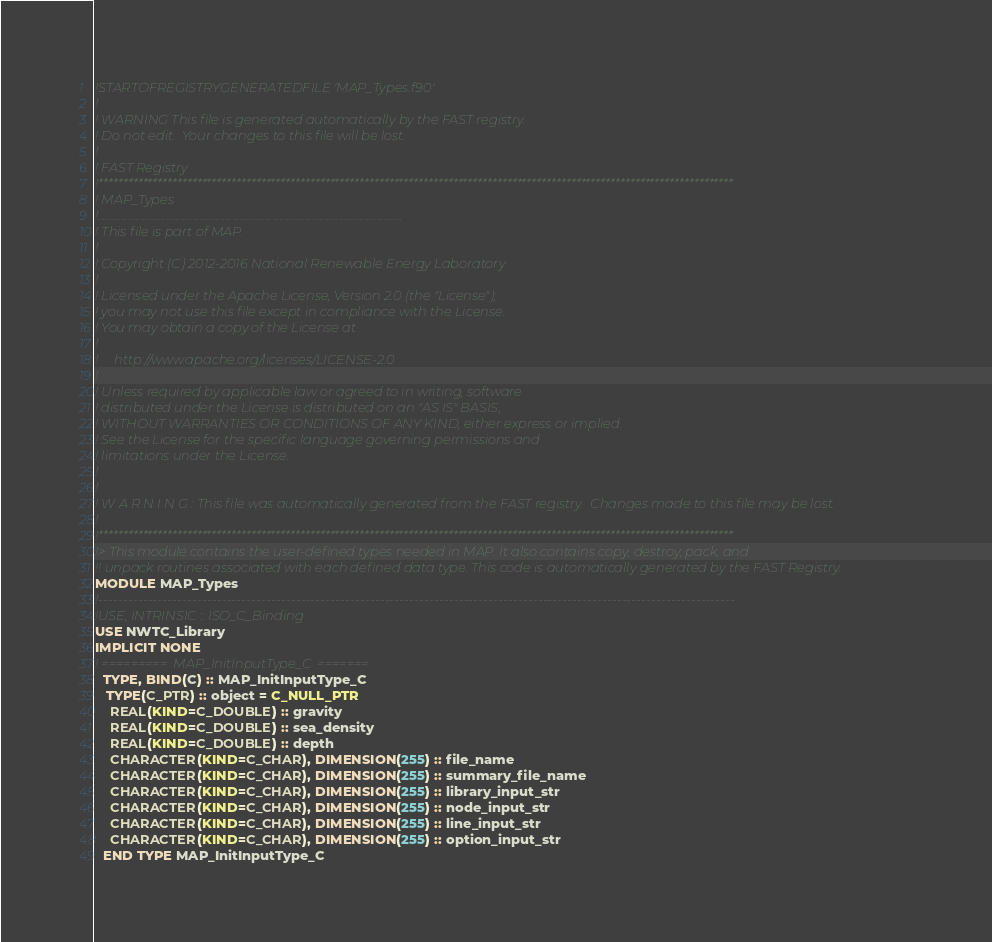Convert code to text. <code><loc_0><loc_0><loc_500><loc_500><_FORTRAN_>!STARTOFREGISTRYGENERATEDFILE 'MAP_Types.f90'
!
! WARNING This file is generated automatically by the FAST registry.
! Do not edit.  Your changes to this file will be lost.
!
! FAST Registry
!*********************************************************************************************************************************
! MAP_Types
!.................................................................................................................................
! This file is part of MAP.
!
! Copyright (C) 2012-2016 National Renewable Energy Laboratory
!
! Licensed under the Apache License, Version 2.0 (the "License");
! you may not use this file except in compliance with the License.
! You may obtain a copy of the License at
!
!     http://www.apache.org/licenses/LICENSE-2.0
!
! Unless required by applicable law or agreed to in writing, software
! distributed under the License is distributed on an "AS IS" BASIS,
! WITHOUT WARRANTIES OR CONDITIONS OF ANY KIND, either express or implied.
! See the License for the specific language governing permissions and
! limitations under the License.
!
!
! W A R N I N G : This file was automatically generated from the FAST registry.  Changes made to this file may be lost.
!
!*********************************************************************************************************************************
!> This module contains the user-defined types needed in MAP. It also contains copy, destroy, pack, and
!! unpack routines associated with each defined data type. This code is automatically generated by the FAST Registry.
MODULE MAP_Types
!---------------------------------------------------------------------------------------------------------------------------------
!USE, INTRINSIC :: ISO_C_Binding
USE NWTC_Library
IMPLICIT NONE
! =========  MAP_InitInputType_C  =======
  TYPE, BIND(C) :: MAP_InitInputType_C
   TYPE(C_PTR) :: object = C_NULL_PTR
    REAL(KIND=C_DOUBLE) :: gravity 
    REAL(KIND=C_DOUBLE) :: sea_density 
    REAL(KIND=C_DOUBLE) :: depth 
    CHARACTER(KIND=C_CHAR), DIMENSION(255) :: file_name 
    CHARACTER(KIND=C_CHAR), DIMENSION(255) :: summary_file_name 
    CHARACTER(KIND=C_CHAR), DIMENSION(255) :: library_input_str 
    CHARACTER(KIND=C_CHAR), DIMENSION(255) :: node_input_str 
    CHARACTER(KIND=C_CHAR), DIMENSION(255) :: line_input_str 
    CHARACTER(KIND=C_CHAR), DIMENSION(255) :: option_input_str 
  END TYPE MAP_InitInputType_C</code> 